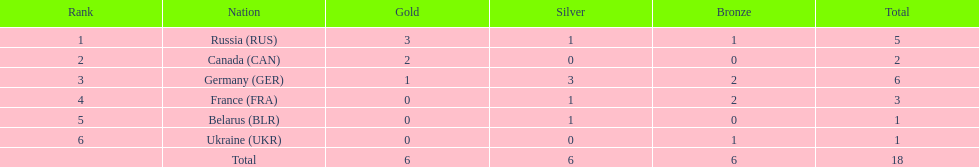During the 1994 winter olympics, which country solely obtained gold medals in the biathlon competition? Canada (CAN). 